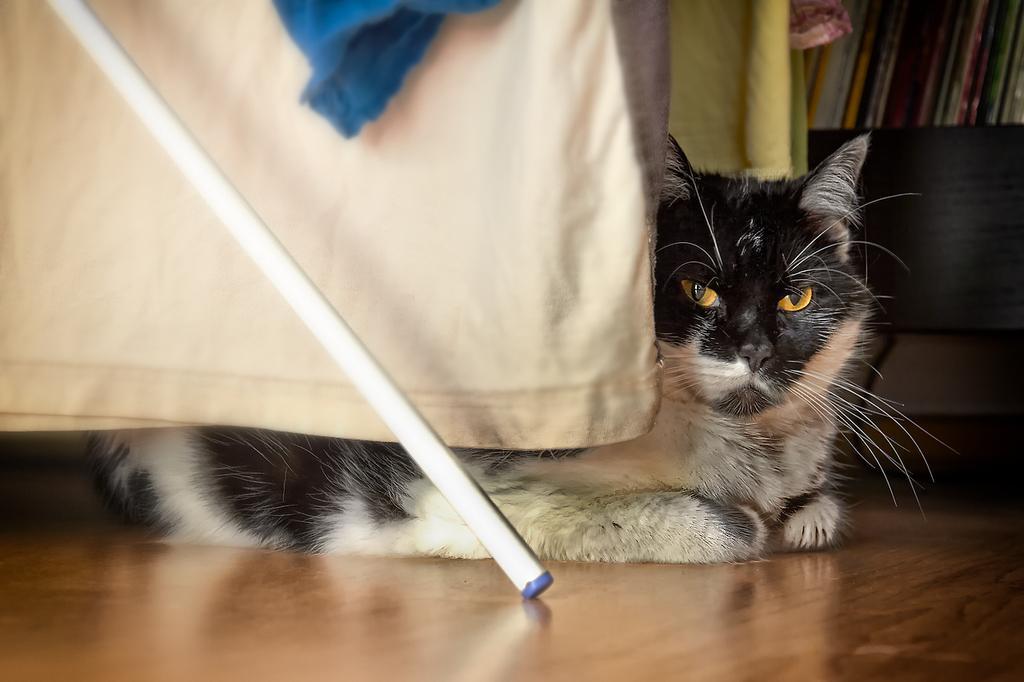Please provide a concise description of this image. In this picture, we see the cat and it is looking at something. Beside that, we see a white cloth and a stand. At the bottom, we see the wooden floor. Behind the cat, we see a yellow color cloth, sofa and a rack in which books are placed. This picture might be clicked inside the room. 